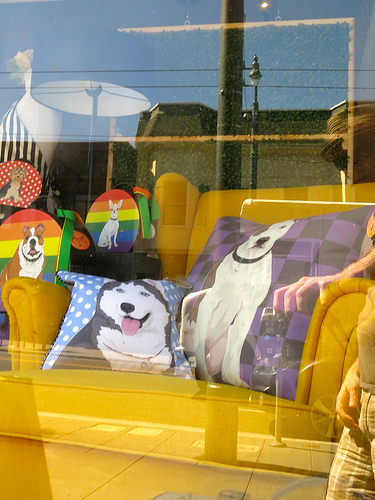<image>
Is the dog on the rainbow? Yes. Looking at the image, I can see the dog is positioned on top of the rainbow, with the rainbow providing support. Is the rainbow next to the lampshade? No. The rainbow is not positioned next to the lampshade. They are located in different areas of the scene. 